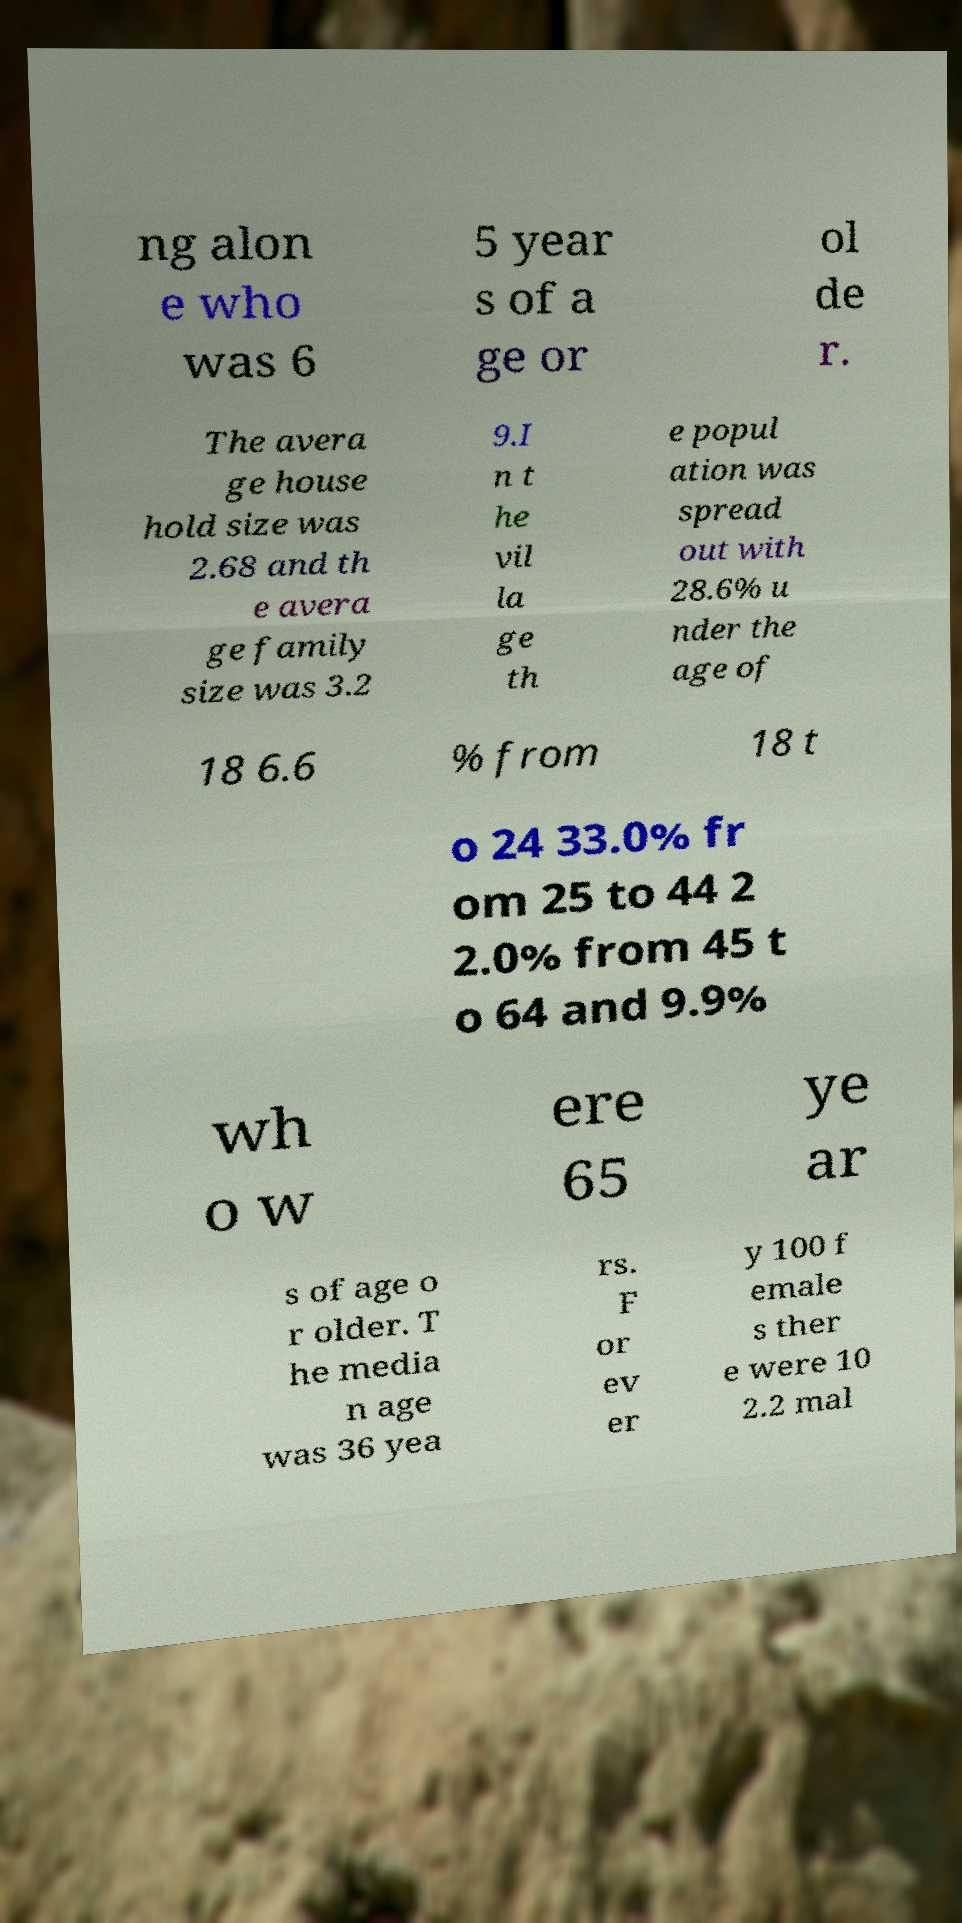Please identify and transcribe the text found in this image. ng alon e who was 6 5 year s of a ge or ol de r. The avera ge house hold size was 2.68 and th e avera ge family size was 3.2 9.I n t he vil la ge th e popul ation was spread out with 28.6% u nder the age of 18 6.6 % from 18 t o 24 33.0% fr om 25 to 44 2 2.0% from 45 t o 64 and 9.9% wh o w ere 65 ye ar s of age o r older. T he media n age was 36 yea rs. F or ev er y 100 f emale s ther e were 10 2.2 mal 